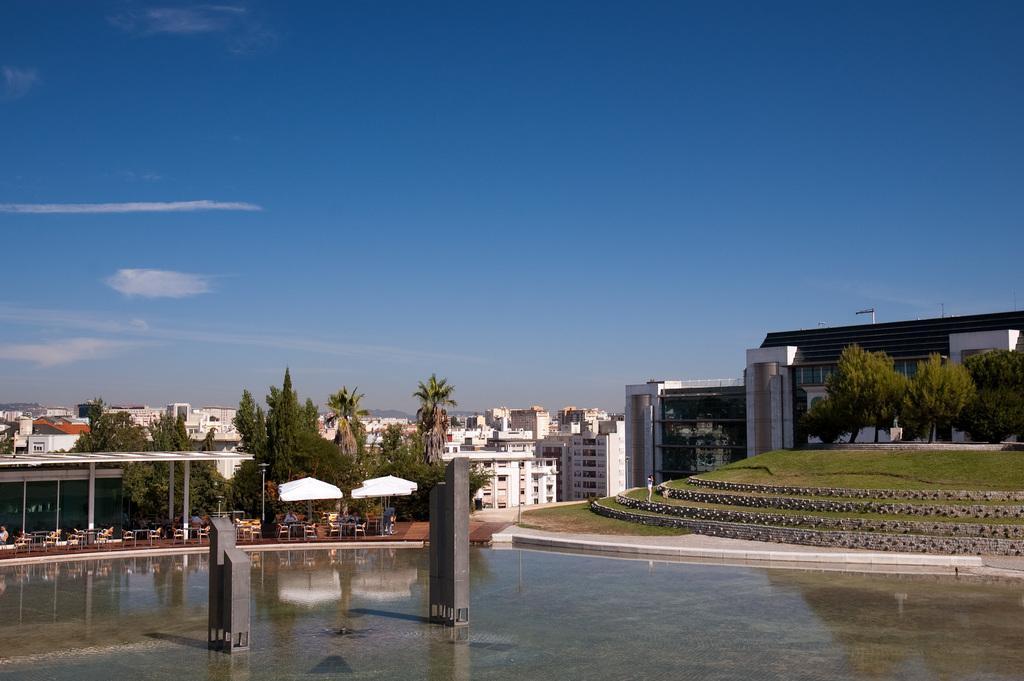Could you give a brief overview of what you see in this image? In this image, we can see buildings, trees, tables, chairs, tents and we can see a flag, some poles and people. At the top, there is sky and at the bottom, there is water. 